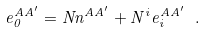<formula> <loc_0><loc_0><loc_500><loc_500>e ^ { A A ^ { \prime } } _ { 0 } = N n ^ { A A ^ { \prime } } + N ^ { i } e ^ { A A ^ { \prime } } _ { i } \ .</formula> 